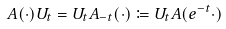Convert formula to latex. <formula><loc_0><loc_0><loc_500><loc_500>A ( \cdot ) U _ { t } = U _ { t } A _ { - t } ( \cdot ) \coloneqq U _ { t } A ( e ^ { - t } \cdot )</formula> 